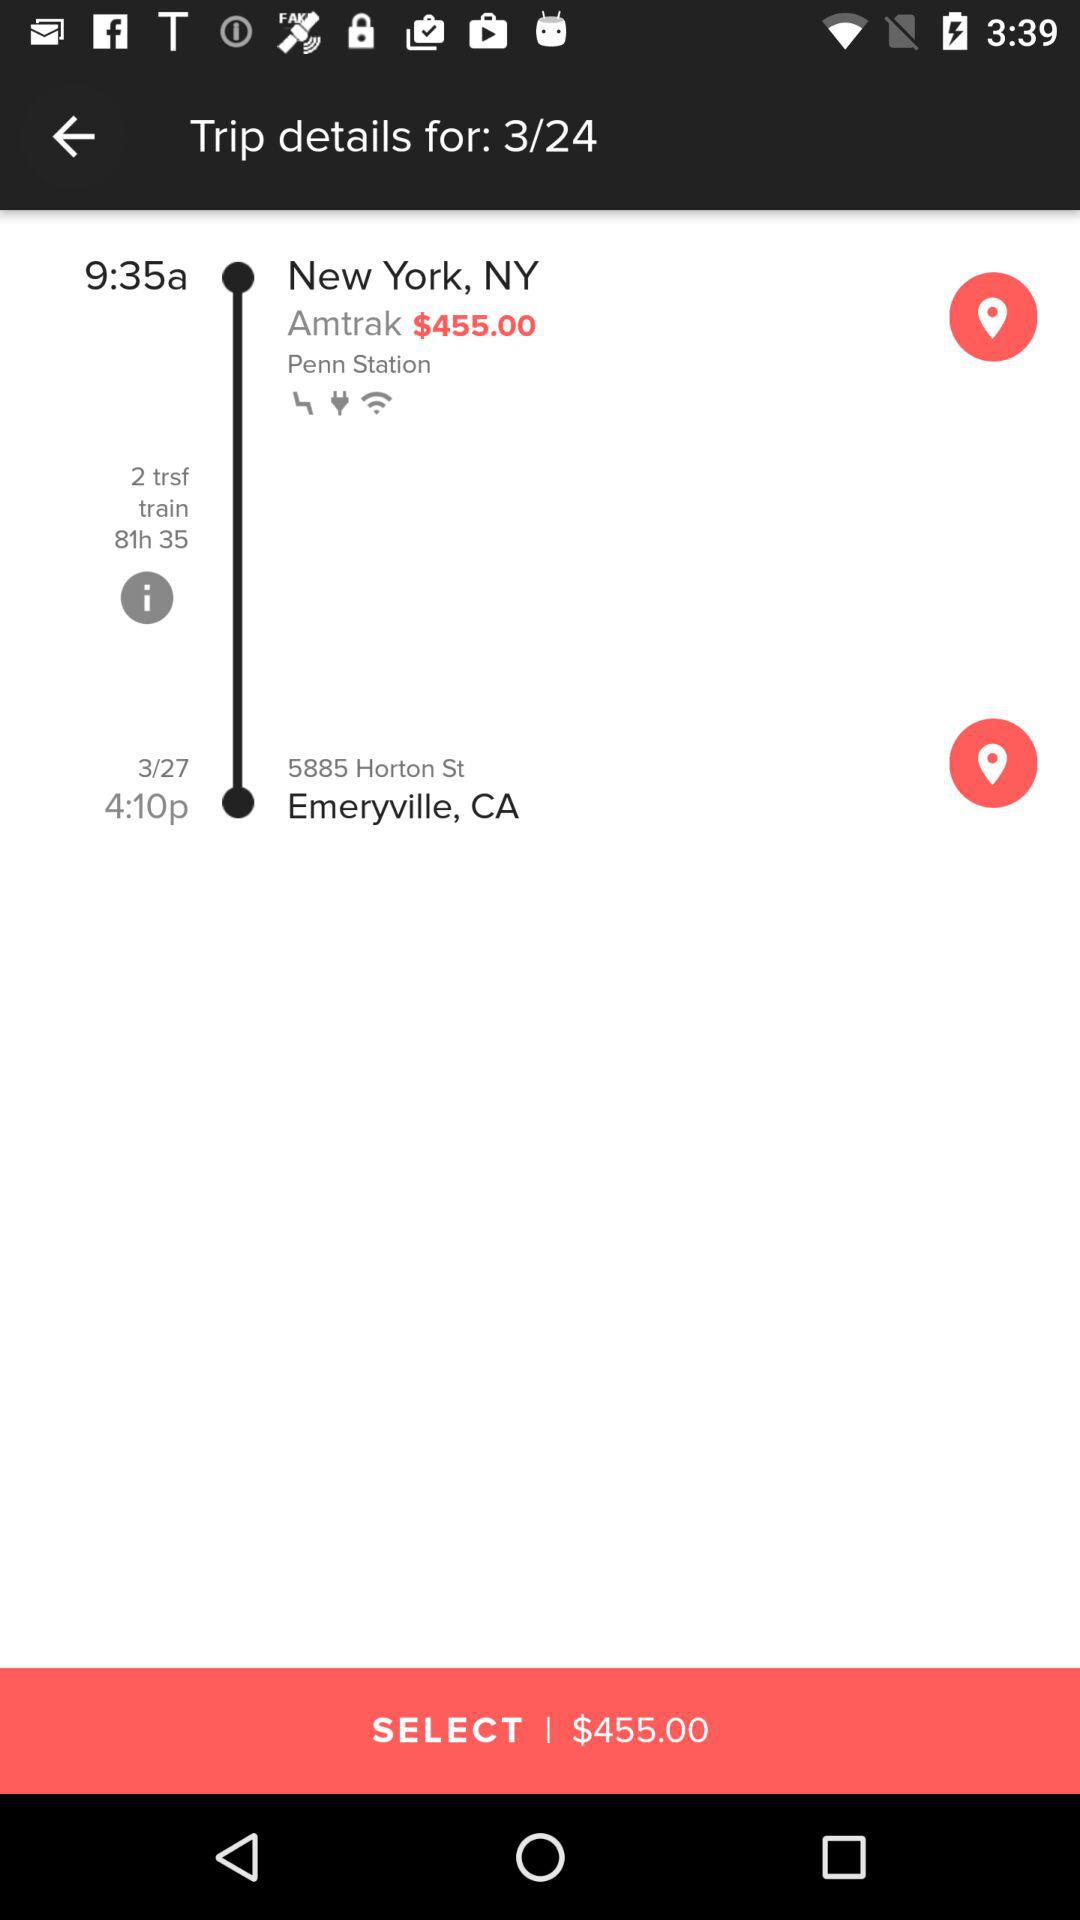What is the trip price for Amtrak? The trip price is $455. 